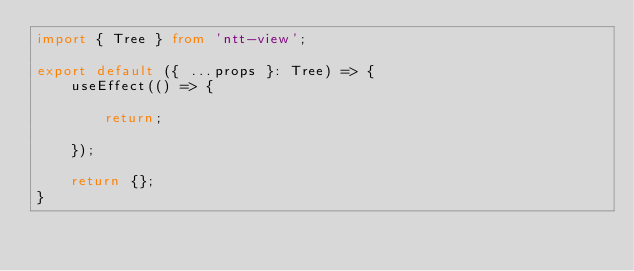<code> <loc_0><loc_0><loc_500><loc_500><_TypeScript_>import { Tree } from 'ntt-view';

export default ({ ...props }: Tree) => {
    useEffect(() => {

        return;

    });

    return {};
}

</code> 